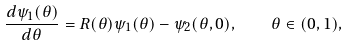<formula> <loc_0><loc_0><loc_500><loc_500>\frac { d \psi _ { 1 } ( \theta ) } { d \theta } = R ( \theta ) \psi _ { 1 } ( \theta ) - \psi _ { 2 } ( \theta , 0 ) , \quad \theta \in ( 0 , 1 ) ,</formula> 